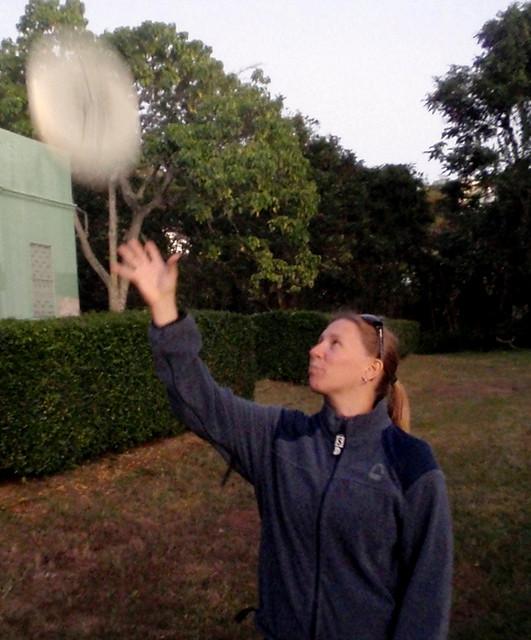Where is the woman wearing her sunglasses?
Give a very brief answer. On her head. Is the woman doing magic?
Quick response, please. No. What holds up her pants?
Short answer required. Belt. What is the woman reaching out for?
Keep it brief. Frisbee. What is on the girl's face?
Keep it brief. Nothing. 